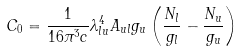Convert formula to latex. <formula><loc_0><loc_0><loc_500><loc_500>C _ { 0 } = \frac { 1 } { 1 6 \pi ^ { 3 } c } \lambda ^ { 4 } _ { l u } A _ { u l } g _ { u } \left ( \frac { N _ { l } } { g _ { l } } - \frac { N _ { u } } { g _ { u } } \right )</formula> 